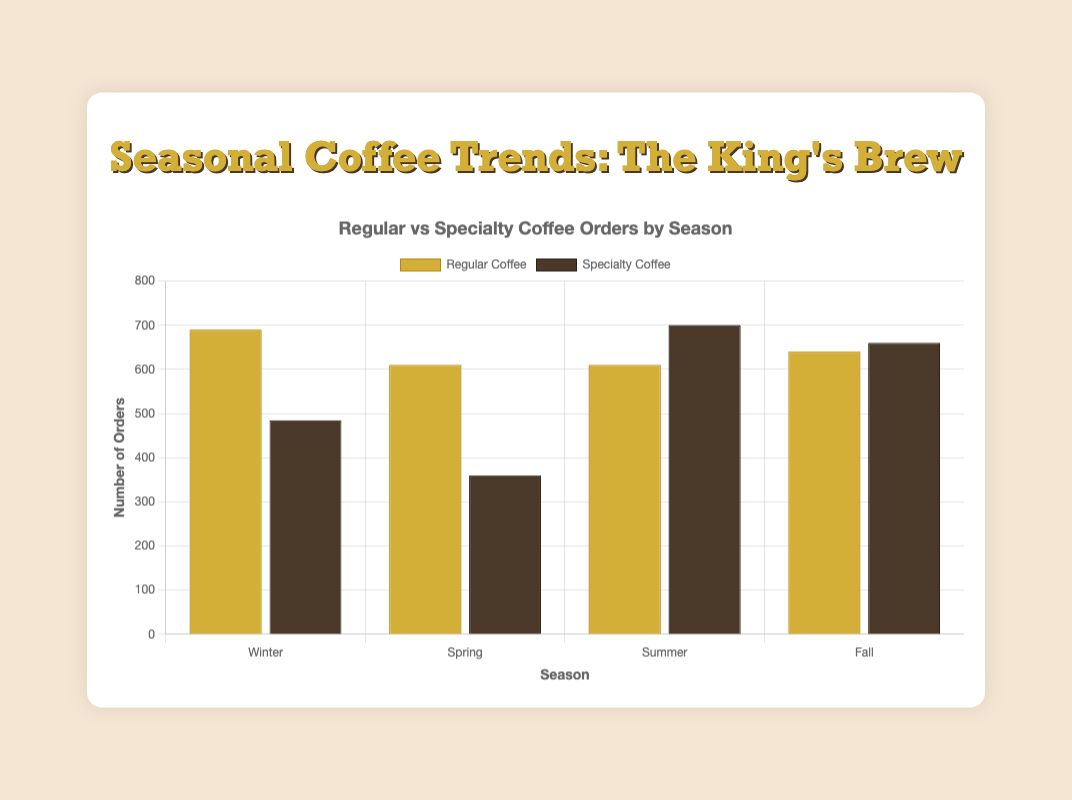What season has the highest number of specialty coffee orders? To find this, look at the height of the bars representing specialty coffee orders across the four seasons. The fall season has the highest number of specialty coffee orders.
Answer: Fall In which season are regular coffee orders the lowest? Compare the heights of the bars representing regular coffee orders for each season. The spring season has the lowest bar for regular coffee orders.
Answer: Spring How many more specialty coffees are ordered in summer compared to spring? First, find the total orders for specialty coffee in summer (240 + 210 + 250 = 700) and spring (130 + 120 + 110 = 360). Subtract the spring total from the summer total to find the difference (700 - 360 = 340).
Answer: 340 Are there more regular or specialty coffee orders in winter? Compare the bars of regular and specialty coffee orders in winter. Sum the orders for regular coffee in winter (230 + 190 + 270 = 690) and specialty coffee in winter (180 + 145 + 160 = 485). The regular coffee orders are higher.
Answer: Regular Which season has the most balanced number of regular and specialty coffee orders? Evaluate the difference between the number of regular and specialty coffee orders for each season. The fall season has a relatively balanced number with regular orders being 640 and specialty being 660, a difference of 20.
Answer: Fall How many more total coffee orders are there in fall compared to spring? Calculate the total coffee orders for fall (regular: 210 + 180 + 250 = 640, specialty: 300 + 170 + 190 = 660, total: 640 + 660 = 1300) and spring (regular: 200 + 170 + 240 = 610, specialty: 130 + 120 + 110 = 360, total: 610 + 360 = 970). The difference is 1300 - 970 = 330.
Answer: 330 What's the average number of regular coffee orders per season? Sum the regular coffee orders across all seasons and divide by 4. (Winter: 690, Spring: 610, Summer: 610, Fall: 640. Total: 690 + 610 + 610 + 640 = 2550). The average is 2550/4 = 637.5.
Answer: 637.5 